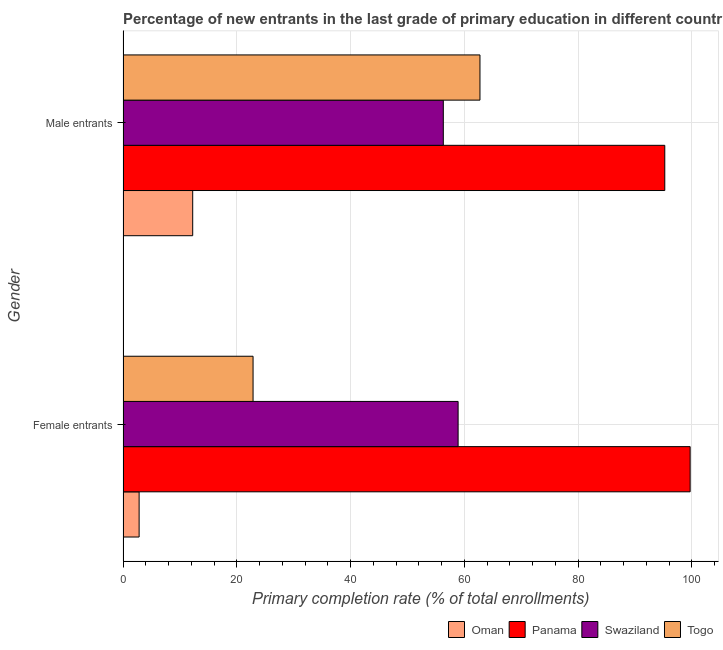How many groups of bars are there?
Give a very brief answer. 2. Are the number of bars per tick equal to the number of legend labels?
Offer a terse response. Yes. Are the number of bars on each tick of the Y-axis equal?
Ensure brevity in your answer.  Yes. What is the label of the 1st group of bars from the top?
Your response must be concise. Male entrants. What is the primary completion rate of female entrants in Swaziland?
Give a very brief answer. 58.91. Across all countries, what is the maximum primary completion rate of male entrants?
Offer a terse response. 95.25. Across all countries, what is the minimum primary completion rate of female entrants?
Provide a succinct answer. 2.83. In which country was the primary completion rate of female entrants maximum?
Your answer should be compact. Panama. In which country was the primary completion rate of male entrants minimum?
Offer a terse response. Oman. What is the total primary completion rate of male entrants in the graph?
Provide a short and direct response. 226.57. What is the difference between the primary completion rate of male entrants in Oman and that in Panama?
Offer a very short reply. -82.99. What is the difference between the primary completion rate of male entrants in Swaziland and the primary completion rate of female entrants in Oman?
Your answer should be very brief. 53.48. What is the average primary completion rate of male entrants per country?
Your response must be concise. 56.64. What is the difference between the primary completion rate of male entrants and primary completion rate of female entrants in Swaziland?
Offer a terse response. -2.6. In how many countries, is the primary completion rate of male entrants greater than 36 %?
Keep it short and to the point. 3. What is the ratio of the primary completion rate of male entrants in Panama to that in Togo?
Your answer should be compact. 1.52. In how many countries, is the primary completion rate of female entrants greater than the average primary completion rate of female entrants taken over all countries?
Provide a succinct answer. 2. What does the 4th bar from the top in Female entrants represents?
Offer a terse response. Oman. What does the 3rd bar from the bottom in Female entrants represents?
Your response must be concise. Swaziland. Are all the bars in the graph horizontal?
Give a very brief answer. Yes. How many countries are there in the graph?
Provide a succinct answer. 4. What is the difference between two consecutive major ticks on the X-axis?
Offer a very short reply. 20. Does the graph contain any zero values?
Provide a succinct answer. No. What is the title of the graph?
Offer a terse response. Percentage of new entrants in the last grade of primary education in different countries. What is the label or title of the X-axis?
Offer a very short reply. Primary completion rate (% of total enrollments). What is the Primary completion rate (% of total enrollments) of Oman in Female entrants?
Keep it short and to the point. 2.83. What is the Primary completion rate (% of total enrollments) in Panama in Female entrants?
Give a very brief answer. 99.7. What is the Primary completion rate (% of total enrollments) in Swaziland in Female entrants?
Provide a succinct answer. 58.91. What is the Primary completion rate (% of total enrollments) in Togo in Female entrants?
Offer a terse response. 22.86. What is the Primary completion rate (% of total enrollments) of Oman in Male entrants?
Your response must be concise. 12.26. What is the Primary completion rate (% of total enrollments) in Panama in Male entrants?
Provide a succinct answer. 95.25. What is the Primary completion rate (% of total enrollments) of Swaziland in Male entrants?
Your response must be concise. 56.31. What is the Primary completion rate (% of total enrollments) in Togo in Male entrants?
Your response must be concise. 62.76. Across all Gender, what is the maximum Primary completion rate (% of total enrollments) in Oman?
Offer a very short reply. 12.26. Across all Gender, what is the maximum Primary completion rate (% of total enrollments) in Panama?
Your answer should be very brief. 99.7. Across all Gender, what is the maximum Primary completion rate (% of total enrollments) in Swaziland?
Give a very brief answer. 58.91. Across all Gender, what is the maximum Primary completion rate (% of total enrollments) in Togo?
Offer a very short reply. 62.76. Across all Gender, what is the minimum Primary completion rate (% of total enrollments) of Oman?
Your answer should be compact. 2.83. Across all Gender, what is the minimum Primary completion rate (% of total enrollments) in Panama?
Provide a succinct answer. 95.25. Across all Gender, what is the minimum Primary completion rate (% of total enrollments) of Swaziland?
Provide a succinct answer. 56.31. Across all Gender, what is the minimum Primary completion rate (% of total enrollments) in Togo?
Keep it short and to the point. 22.86. What is the total Primary completion rate (% of total enrollments) of Oman in the graph?
Keep it short and to the point. 15.09. What is the total Primary completion rate (% of total enrollments) of Panama in the graph?
Make the answer very short. 194.95. What is the total Primary completion rate (% of total enrollments) in Swaziland in the graph?
Offer a terse response. 115.23. What is the total Primary completion rate (% of total enrollments) in Togo in the graph?
Give a very brief answer. 85.62. What is the difference between the Primary completion rate (% of total enrollments) of Oman in Female entrants and that in Male entrants?
Provide a succinct answer. -9.42. What is the difference between the Primary completion rate (% of total enrollments) of Panama in Female entrants and that in Male entrants?
Provide a succinct answer. 4.46. What is the difference between the Primary completion rate (% of total enrollments) of Swaziland in Female entrants and that in Male entrants?
Provide a short and direct response. 2.6. What is the difference between the Primary completion rate (% of total enrollments) in Togo in Female entrants and that in Male entrants?
Ensure brevity in your answer.  -39.89. What is the difference between the Primary completion rate (% of total enrollments) of Oman in Female entrants and the Primary completion rate (% of total enrollments) of Panama in Male entrants?
Provide a succinct answer. -92.41. What is the difference between the Primary completion rate (% of total enrollments) in Oman in Female entrants and the Primary completion rate (% of total enrollments) in Swaziland in Male entrants?
Make the answer very short. -53.48. What is the difference between the Primary completion rate (% of total enrollments) in Oman in Female entrants and the Primary completion rate (% of total enrollments) in Togo in Male entrants?
Your response must be concise. -59.92. What is the difference between the Primary completion rate (% of total enrollments) of Panama in Female entrants and the Primary completion rate (% of total enrollments) of Swaziland in Male entrants?
Make the answer very short. 43.39. What is the difference between the Primary completion rate (% of total enrollments) in Panama in Female entrants and the Primary completion rate (% of total enrollments) in Togo in Male entrants?
Provide a short and direct response. 36.95. What is the difference between the Primary completion rate (% of total enrollments) of Swaziland in Female entrants and the Primary completion rate (% of total enrollments) of Togo in Male entrants?
Your response must be concise. -3.84. What is the average Primary completion rate (% of total enrollments) of Oman per Gender?
Give a very brief answer. 7.55. What is the average Primary completion rate (% of total enrollments) of Panama per Gender?
Offer a terse response. 97.48. What is the average Primary completion rate (% of total enrollments) of Swaziland per Gender?
Your answer should be compact. 57.61. What is the average Primary completion rate (% of total enrollments) in Togo per Gender?
Your response must be concise. 42.81. What is the difference between the Primary completion rate (% of total enrollments) in Oman and Primary completion rate (% of total enrollments) in Panama in Female entrants?
Provide a succinct answer. -96.87. What is the difference between the Primary completion rate (% of total enrollments) in Oman and Primary completion rate (% of total enrollments) in Swaziland in Female entrants?
Keep it short and to the point. -56.08. What is the difference between the Primary completion rate (% of total enrollments) in Oman and Primary completion rate (% of total enrollments) in Togo in Female entrants?
Ensure brevity in your answer.  -20.03. What is the difference between the Primary completion rate (% of total enrollments) of Panama and Primary completion rate (% of total enrollments) of Swaziland in Female entrants?
Your answer should be very brief. 40.79. What is the difference between the Primary completion rate (% of total enrollments) in Panama and Primary completion rate (% of total enrollments) in Togo in Female entrants?
Ensure brevity in your answer.  76.84. What is the difference between the Primary completion rate (% of total enrollments) of Swaziland and Primary completion rate (% of total enrollments) of Togo in Female entrants?
Offer a very short reply. 36.05. What is the difference between the Primary completion rate (% of total enrollments) of Oman and Primary completion rate (% of total enrollments) of Panama in Male entrants?
Your response must be concise. -82.99. What is the difference between the Primary completion rate (% of total enrollments) of Oman and Primary completion rate (% of total enrollments) of Swaziland in Male entrants?
Offer a terse response. -44.06. What is the difference between the Primary completion rate (% of total enrollments) of Oman and Primary completion rate (% of total enrollments) of Togo in Male entrants?
Offer a very short reply. -50.5. What is the difference between the Primary completion rate (% of total enrollments) in Panama and Primary completion rate (% of total enrollments) in Swaziland in Male entrants?
Make the answer very short. 38.94. What is the difference between the Primary completion rate (% of total enrollments) of Panama and Primary completion rate (% of total enrollments) of Togo in Male entrants?
Your response must be concise. 32.49. What is the difference between the Primary completion rate (% of total enrollments) of Swaziland and Primary completion rate (% of total enrollments) of Togo in Male entrants?
Keep it short and to the point. -6.44. What is the ratio of the Primary completion rate (% of total enrollments) of Oman in Female entrants to that in Male entrants?
Offer a terse response. 0.23. What is the ratio of the Primary completion rate (% of total enrollments) in Panama in Female entrants to that in Male entrants?
Give a very brief answer. 1.05. What is the ratio of the Primary completion rate (% of total enrollments) in Swaziland in Female entrants to that in Male entrants?
Offer a terse response. 1.05. What is the ratio of the Primary completion rate (% of total enrollments) in Togo in Female entrants to that in Male entrants?
Provide a succinct answer. 0.36. What is the difference between the highest and the second highest Primary completion rate (% of total enrollments) in Oman?
Offer a very short reply. 9.42. What is the difference between the highest and the second highest Primary completion rate (% of total enrollments) of Panama?
Offer a very short reply. 4.46. What is the difference between the highest and the second highest Primary completion rate (% of total enrollments) of Swaziland?
Keep it short and to the point. 2.6. What is the difference between the highest and the second highest Primary completion rate (% of total enrollments) of Togo?
Make the answer very short. 39.89. What is the difference between the highest and the lowest Primary completion rate (% of total enrollments) of Oman?
Offer a terse response. 9.42. What is the difference between the highest and the lowest Primary completion rate (% of total enrollments) of Panama?
Offer a very short reply. 4.46. What is the difference between the highest and the lowest Primary completion rate (% of total enrollments) of Swaziland?
Your response must be concise. 2.6. What is the difference between the highest and the lowest Primary completion rate (% of total enrollments) in Togo?
Your answer should be very brief. 39.89. 